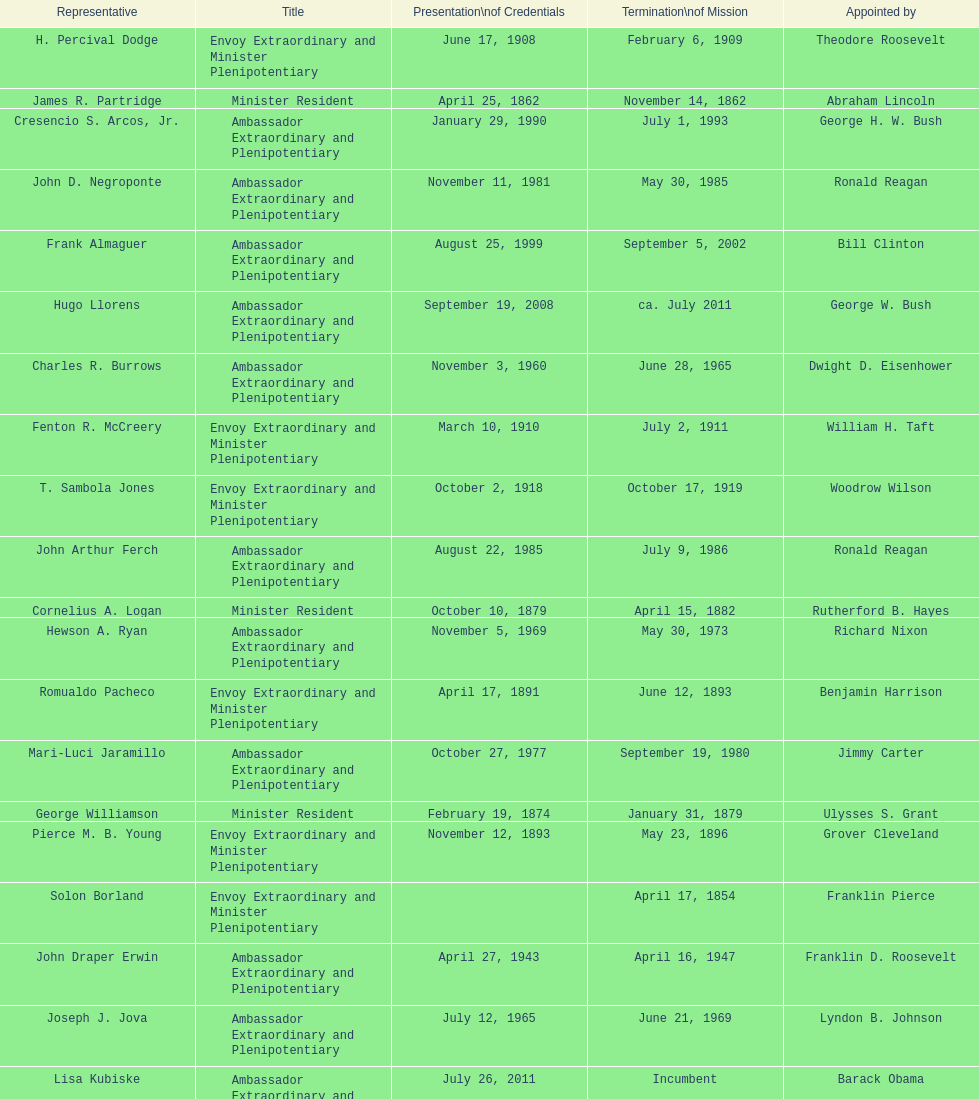Is solon borland a representative? Yes. 